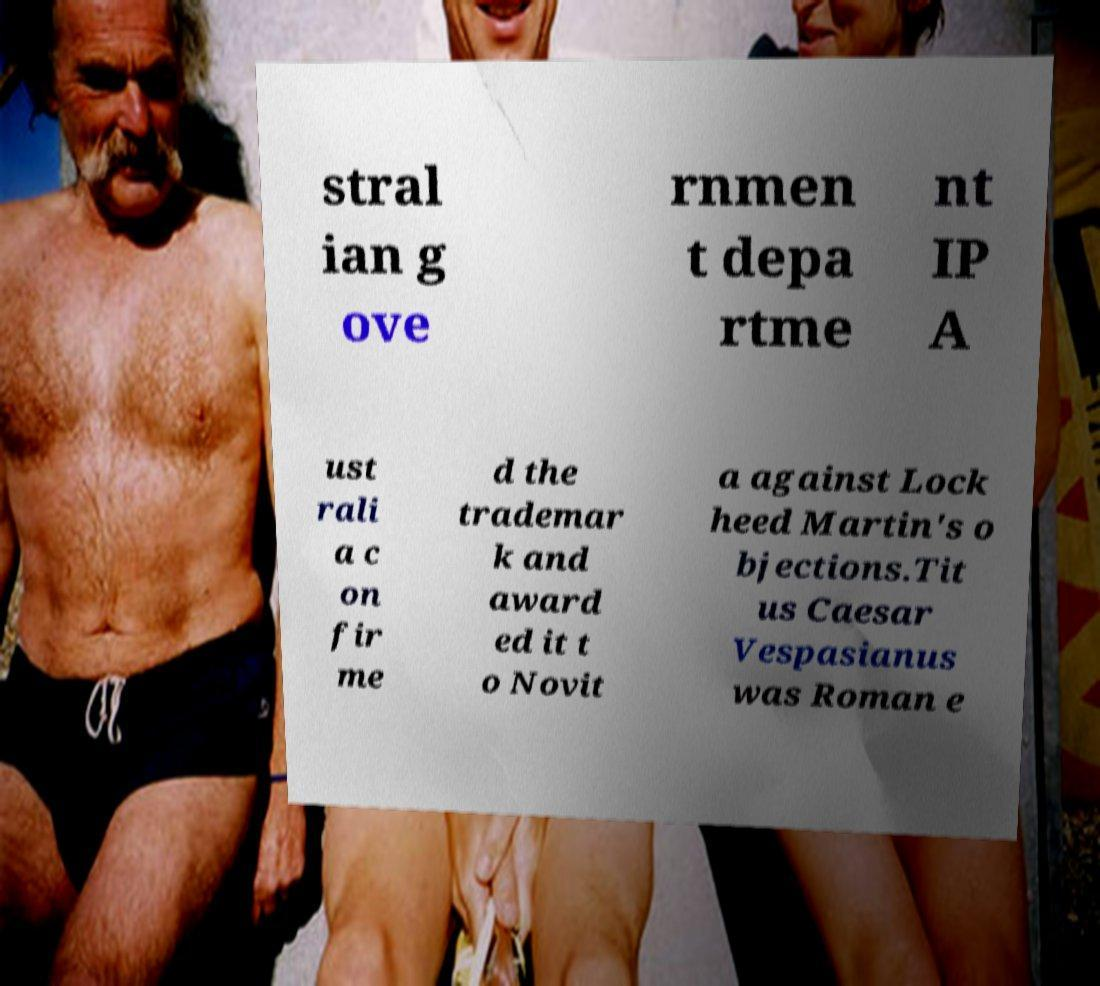Could you assist in decoding the text presented in this image and type it out clearly? stral ian g ove rnmen t depa rtme nt IP A ust rali a c on fir me d the trademar k and award ed it t o Novit a against Lock heed Martin's o bjections.Tit us Caesar Vespasianus was Roman e 